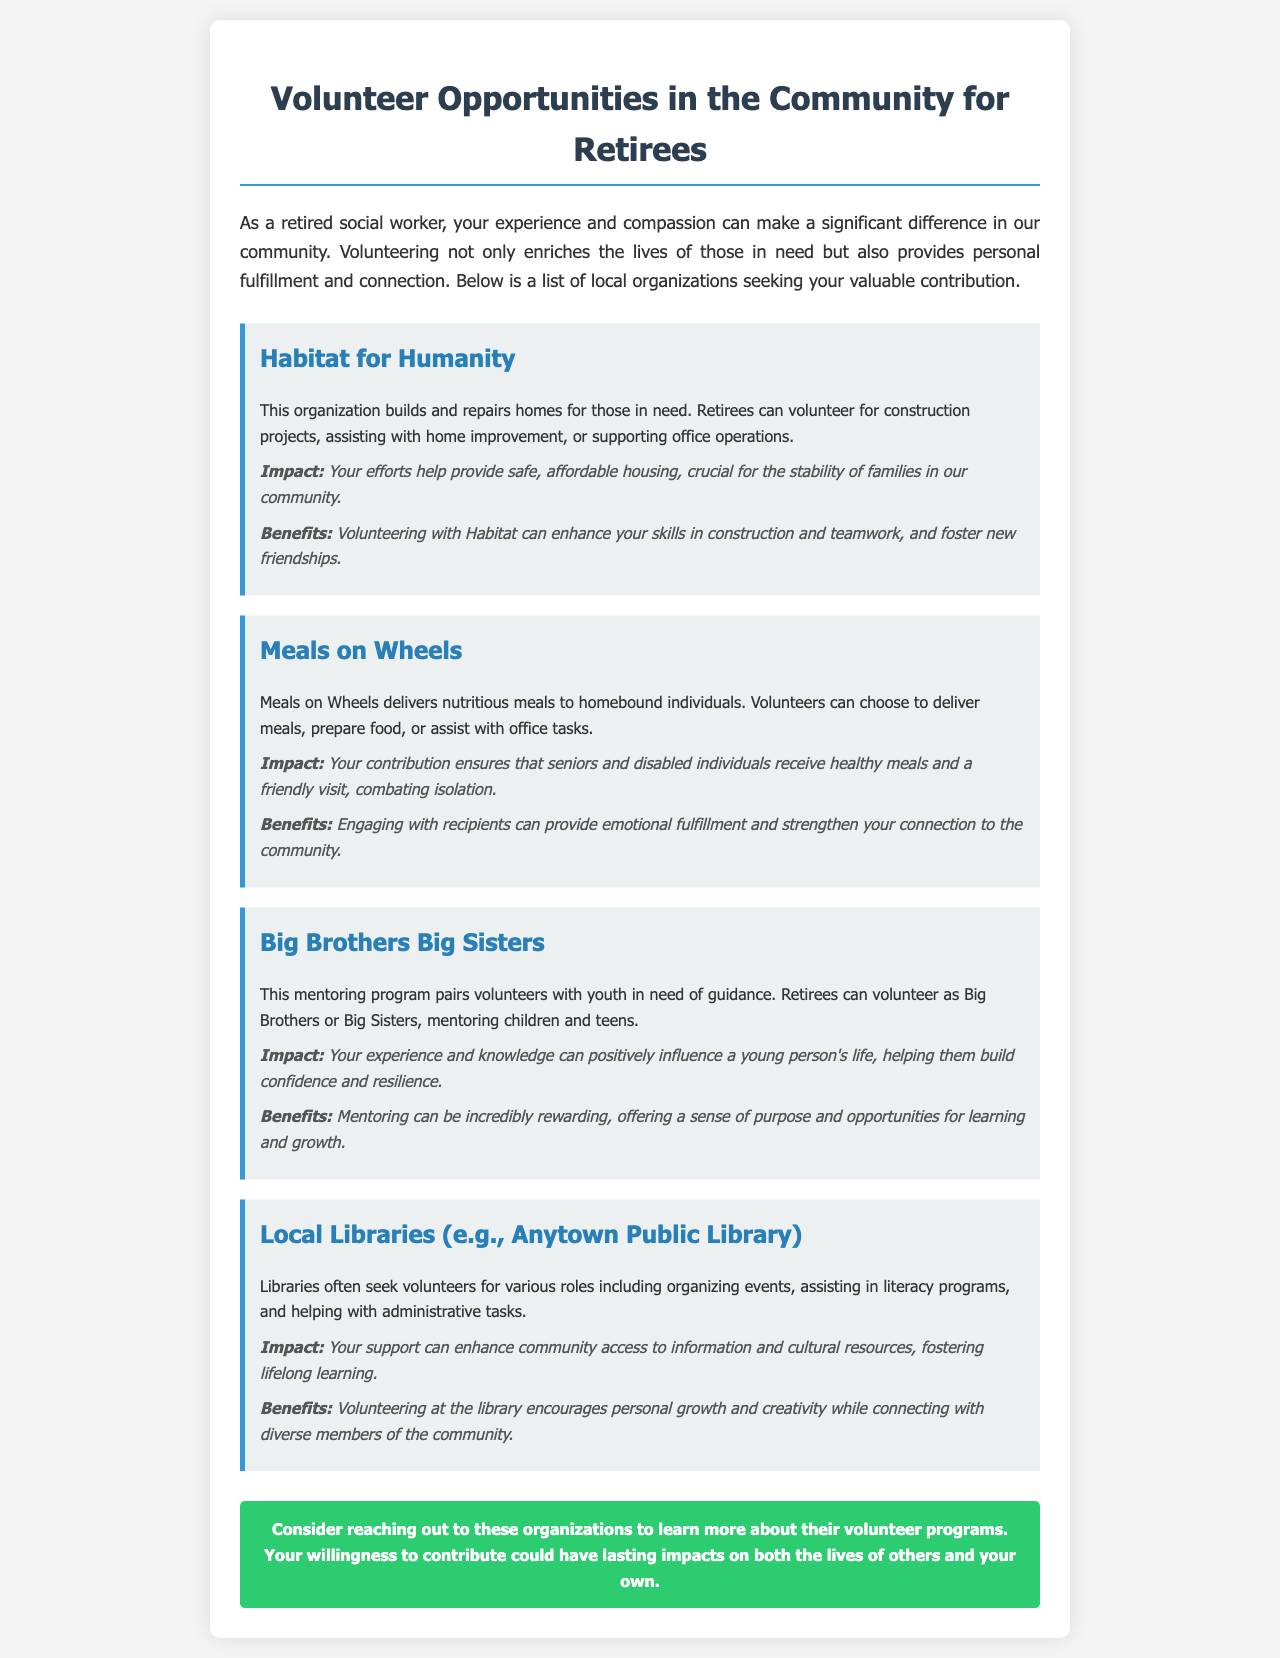What is the title of the newsletter? The title of the newsletter is presented prominently at the top of the document.
Answer: Volunteer Opportunities in the Community for Retirees What organization helps build and repair homes? This information is found in the section describing the first organization.
Answer: Habitat for Humanity What type of meals does Meals on Wheels deliver? This detail can be found in the description of Meals on Wheels in the document.
Answer: Nutritious meals Who can serve as mentors in Big Brothers Big Sisters? The answer is derived from the description of the mentorship program in the document.
Answer: Retirees What is a benefit of volunteering with Habitat for Humanity? The document outlines benefits associated with each organization.
Answer: Enhancing skills in construction How many main organizations are listed for volunteer opportunities? The total number of organizations can be counted from the sections in the document.
Answer: Four What is the main impact of volunteering for Meals on Wheels? This is stated in the impact section of the Meals on Wheels description.
Answer: Ensures healthy meals Where can retirees volunteer to assist with literacy programs? The document specifies locations where retirees can volunteer.
Answer: Local Libraries 